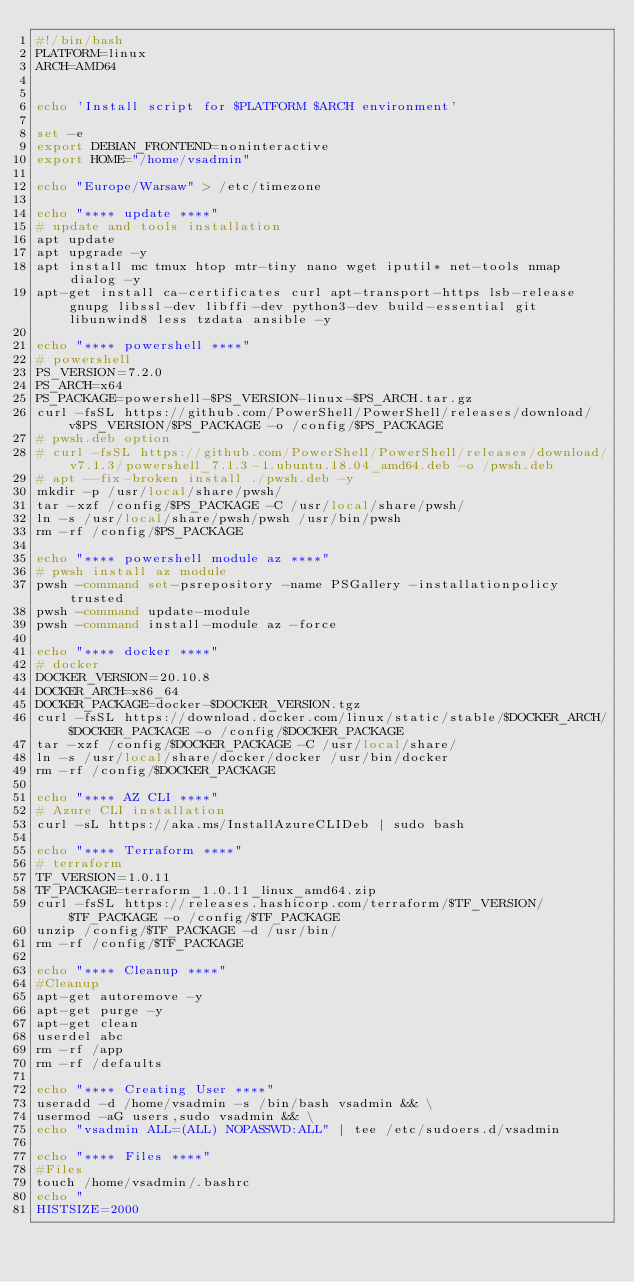Convert code to text. <code><loc_0><loc_0><loc_500><loc_500><_Bash_>#!/bin/bash
PLATFORM=linux
ARCH=AMD64


echo 'Install script for $PLATFORM $ARCH environment'

set -e
export DEBIAN_FRONTEND=noninteractive
export HOME="/home/vsadmin"

echo "Europe/Warsaw" > /etc/timezone

echo "**** update ****" 
# update and tools installation
apt update
apt upgrade -y
apt install mc tmux htop mtr-tiny nano wget iputil* net-tools nmap dialog -y
apt-get install ca-certificates curl apt-transport-https lsb-release gnupg libssl-dev libffi-dev python3-dev build-essential git libunwind8 less tzdata ansible -y

echo "**** powershell ****"
# powershell
PS_VERSION=7.2.0
PS_ARCH=x64
PS_PACKAGE=powershell-$PS_VERSION-linux-$PS_ARCH.tar.gz
curl -fsSL https://github.com/PowerShell/PowerShell/releases/download/v$PS_VERSION/$PS_PACKAGE -o /config/$PS_PACKAGE
# pwsh.deb option
# curl -fsSL https://github.com/PowerShell/PowerShell/releases/download/v7.1.3/powershell_7.1.3-1.ubuntu.18.04_amd64.deb -o /pwsh.deb
# apt --fix-broken install ./pwsh.deb -y
mkdir -p /usr/local/share/pwsh/
tar -xzf /config/$PS_PACKAGE -C /usr/local/share/pwsh/
ln -s /usr/local/share/pwsh/pwsh /usr/bin/pwsh
rm -rf /config/$PS_PACKAGE

echo "**** powershell module az ****" 
# pwsh install az module
pwsh -command set-psrepository -name PSGallery -installationpolicy trusted
pwsh -command update-module
pwsh -command install-module az -force

echo "**** docker ****" 
# docker
DOCKER_VERSION=20.10.8
DOCKER_ARCH=x86_64
DOCKER_PACKAGE=docker-$DOCKER_VERSION.tgz
curl -fsSL https://download.docker.com/linux/static/stable/$DOCKER_ARCH/$DOCKER_PACKAGE -o /config/$DOCKER_PACKAGE
tar -xzf /config/$DOCKER_PACKAGE -C /usr/local/share/
ln -s /usr/local/share/docker/docker /usr/bin/docker
rm -rf /config/$DOCKER_PACKAGE

echo "**** AZ CLI ****" 
# Azure CLI installation
curl -sL https://aka.ms/InstallAzureCLIDeb | sudo bash

echo "**** Terraform ****" 
# terraform
TF_VERSION=1.0.11
TF_PACKAGE=terraform_1.0.11_linux_amd64.zip
curl -fsSL https://releases.hashicorp.com/terraform/$TF_VERSION/$TF_PACKAGE -o /config/$TF_PACKAGE
unzip /config/$TF_PACKAGE -d /usr/bin/
rm -rf /config/$TF_PACKAGE

echo "**** Cleanup ****" 
#Cleanup
apt-get autoremove -y
apt-get purge -y
apt-get clean
userdel abc
rm -rf /app
rm -rf /defaults

echo "**** Creating User ****"
useradd -d /home/vsadmin -s /bin/bash vsadmin && \
usermod -aG users,sudo vsadmin && \
echo "vsadmin ALL=(ALL) NOPASSWD:ALL" | tee /etc/sudoers.d/vsadmin

echo "**** Files ****" 
#Files
touch /home/vsadmin/.bashrc
echo "
HISTSIZE=2000</code> 